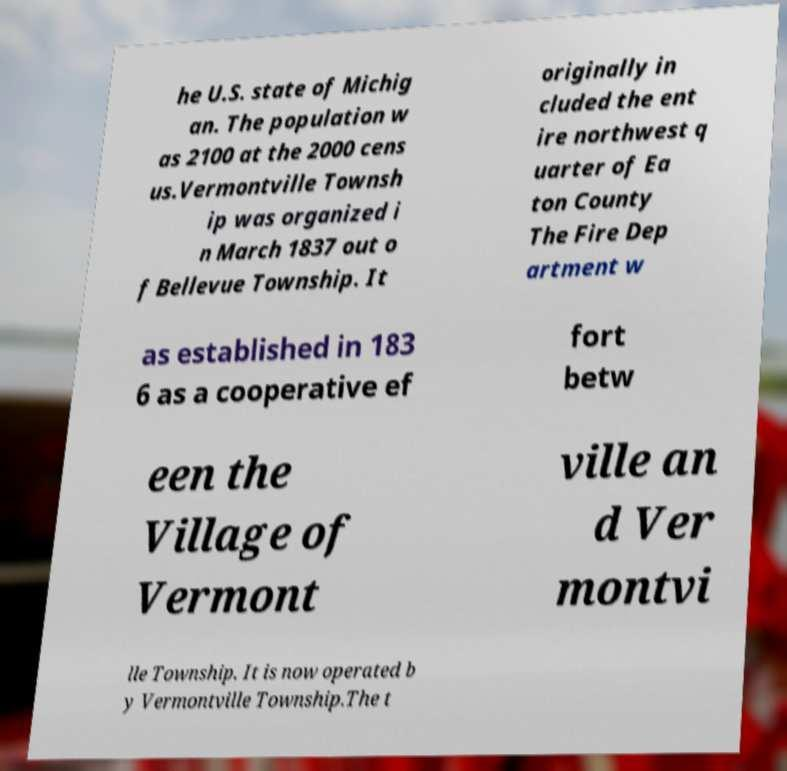Could you extract and type out the text from this image? he U.S. state of Michig an. The population w as 2100 at the 2000 cens us.Vermontville Townsh ip was organized i n March 1837 out o f Bellevue Township. It originally in cluded the ent ire northwest q uarter of Ea ton County The Fire Dep artment w as established in 183 6 as a cooperative ef fort betw een the Village of Vermont ville an d Ver montvi lle Township. It is now operated b y Vermontville Township.The t 